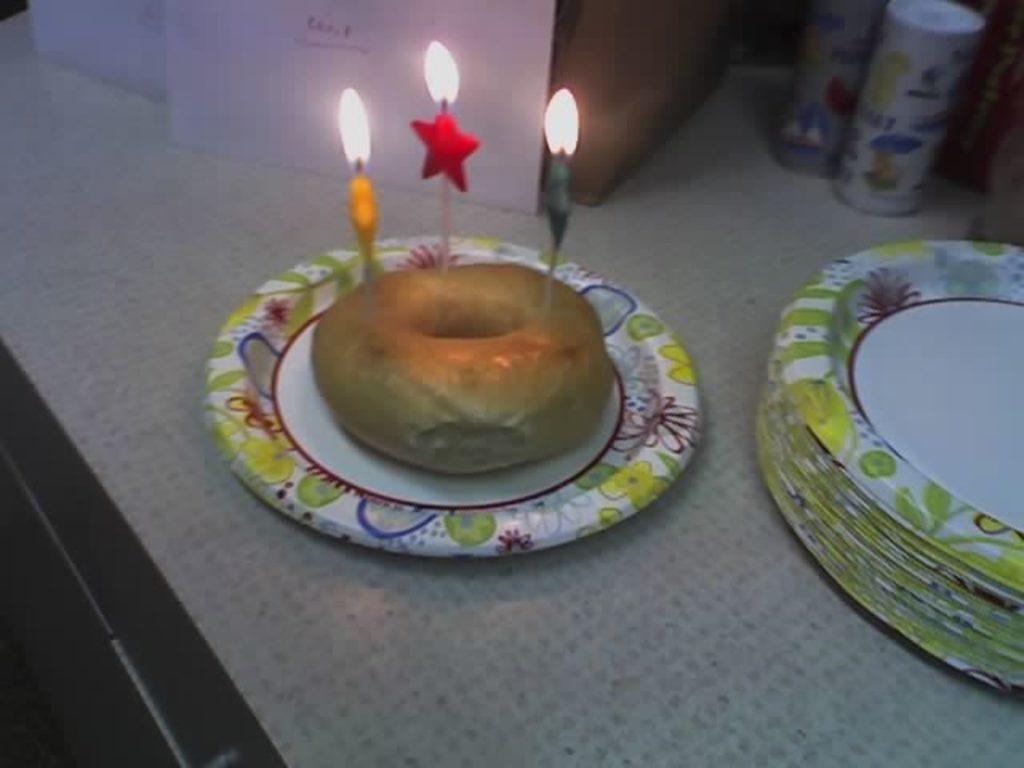In one or two sentences, can you explain what this image depicts? In this image we can see a serving plate which has a donut and candles on the top of it. In the background we can see party confetti and serving plates placed on the table. 